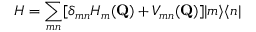<formula> <loc_0><loc_0><loc_500><loc_500>H = \sum _ { m n } [ \delta _ { m n } H _ { m } ( Q ) + V _ { m n } ( Q ) ] | m \rangle \langle n |</formula> 